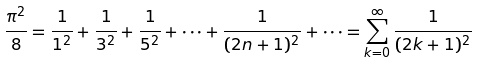<formula> <loc_0><loc_0><loc_500><loc_500>\frac { \pi ^ { 2 } } { 8 } = \frac { 1 } { 1 ^ { 2 } } + \frac { 1 } { 3 ^ { 2 } } + \frac { 1 } { 5 ^ { 2 } } + \dots + \frac { 1 } { ( 2 n + 1 ) ^ { 2 } } + \dots = \sum _ { k = 0 } ^ { \infty } \frac { 1 } { ( 2 k + 1 ) ^ { 2 } }</formula> 